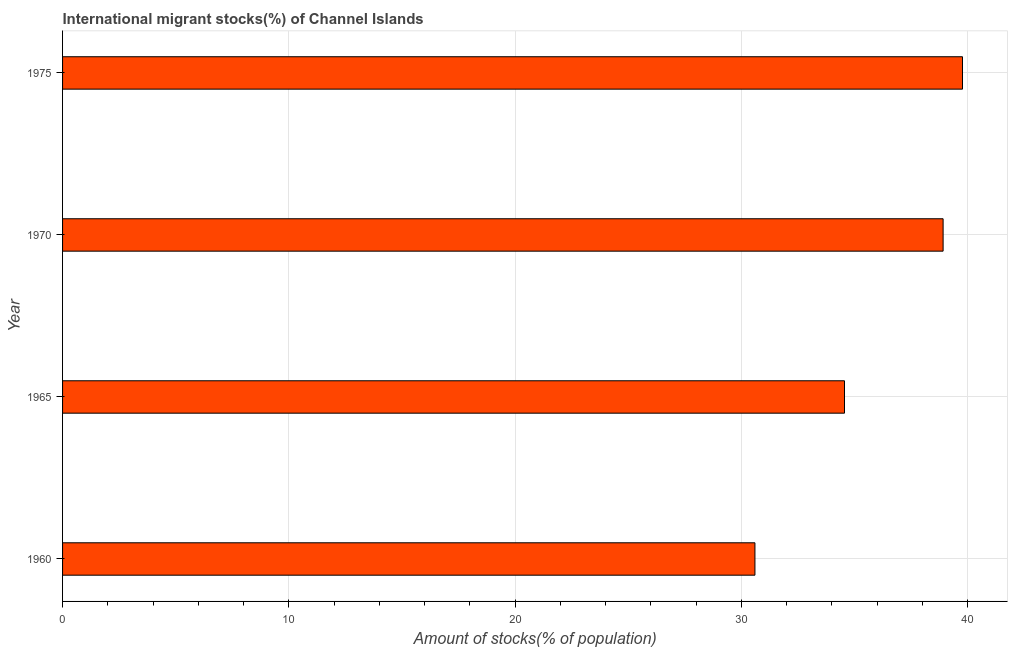Does the graph contain grids?
Your answer should be compact. Yes. What is the title of the graph?
Make the answer very short. International migrant stocks(%) of Channel Islands. What is the label or title of the X-axis?
Offer a very short reply. Amount of stocks(% of population). What is the label or title of the Y-axis?
Make the answer very short. Year. What is the number of international migrant stocks in 1975?
Ensure brevity in your answer.  39.77. Across all years, what is the maximum number of international migrant stocks?
Offer a very short reply. 39.77. Across all years, what is the minimum number of international migrant stocks?
Keep it short and to the point. 30.6. In which year was the number of international migrant stocks maximum?
Ensure brevity in your answer.  1975. In which year was the number of international migrant stocks minimum?
Your answer should be very brief. 1960. What is the sum of the number of international migrant stocks?
Your answer should be compact. 143.85. What is the difference between the number of international migrant stocks in 1960 and 1970?
Keep it short and to the point. -8.32. What is the average number of international migrant stocks per year?
Your answer should be very brief. 35.96. What is the median number of international migrant stocks?
Your response must be concise. 36.74. In how many years, is the number of international migrant stocks greater than 24 %?
Provide a short and direct response. 4. What is the ratio of the number of international migrant stocks in 1970 to that in 1975?
Keep it short and to the point. 0.98. Is the difference between the number of international migrant stocks in 1960 and 1965 greater than the difference between any two years?
Your response must be concise. No. What is the difference between the highest and the second highest number of international migrant stocks?
Ensure brevity in your answer.  0.86. Is the sum of the number of international migrant stocks in 1960 and 1965 greater than the maximum number of international migrant stocks across all years?
Your answer should be very brief. Yes. What is the difference between the highest and the lowest number of international migrant stocks?
Your answer should be very brief. 9.17. In how many years, is the number of international migrant stocks greater than the average number of international migrant stocks taken over all years?
Offer a very short reply. 2. How many bars are there?
Your answer should be compact. 4. What is the difference between two consecutive major ticks on the X-axis?
Your answer should be compact. 10. Are the values on the major ticks of X-axis written in scientific E-notation?
Your response must be concise. No. What is the Amount of stocks(% of population) of 1960?
Offer a terse response. 30.6. What is the Amount of stocks(% of population) in 1965?
Your answer should be compact. 34.56. What is the Amount of stocks(% of population) in 1970?
Offer a terse response. 38.92. What is the Amount of stocks(% of population) of 1975?
Offer a terse response. 39.77. What is the difference between the Amount of stocks(% of population) in 1960 and 1965?
Your answer should be very brief. -3.96. What is the difference between the Amount of stocks(% of population) in 1960 and 1970?
Your response must be concise. -8.32. What is the difference between the Amount of stocks(% of population) in 1960 and 1975?
Offer a very short reply. -9.17. What is the difference between the Amount of stocks(% of population) in 1965 and 1970?
Your response must be concise. -4.36. What is the difference between the Amount of stocks(% of population) in 1965 and 1975?
Ensure brevity in your answer.  -5.22. What is the difference between the Amount of stocks(% of population) in 1970 and 1975?
Offer a very short reply. -0.86. What is the ratio of the Amount of stocks(% of population) in 1960 to that in 1965?
Make the answer very short. 0.89. What is the ratio of the Amount of stocks(% of population) in 1960 to that in 1970?
Ensure brevity in your answer.  0.79. What is the ratio of the Amount of stocks(% of population) in 1960 to that in 1975?
Keep it short and to the point. 0.77. What is the ratio of the Amount of stocks(% of population) in 1965 to that in 1970?
Give a very brief answer. 0.89. What is the ratio of the Amount of stocks(% of population) in 1965 to that in 1975?
Offer a very short reply. 0.87. 